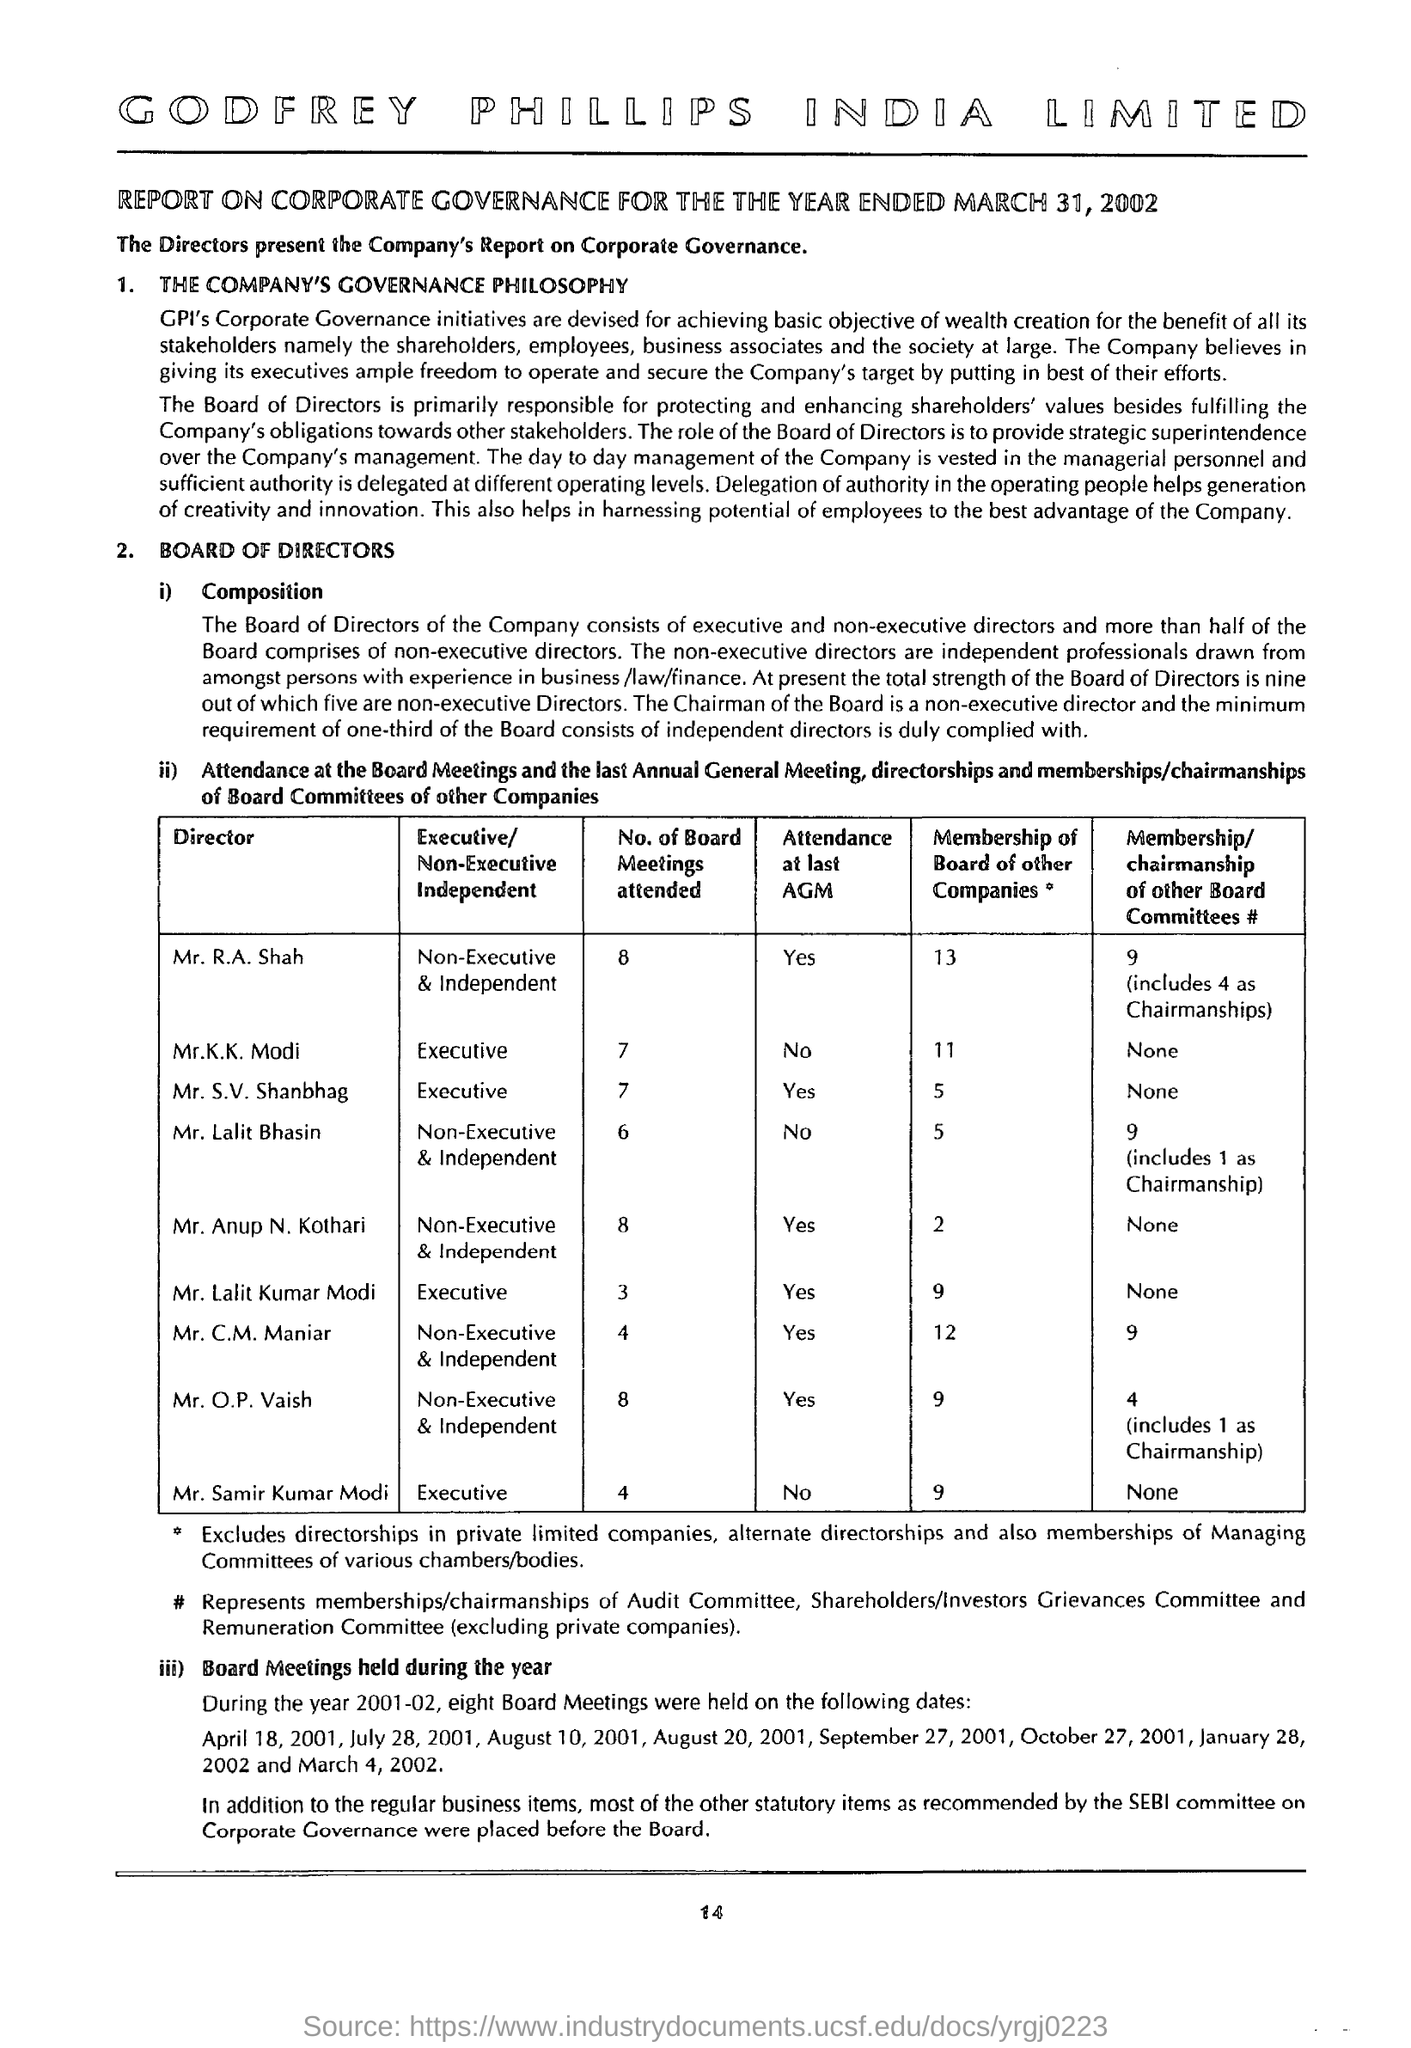Mention a couple of crucial points in this snapshot. There are 12 memberships of the board of other companies for Mr. C.M. Maniar, the director. The director, Mr. O.P. Vaish, attended 8 board meetings. The attendance of Mr. Anup N. Kothari at the last AGM was "yes. The status of attendance at the last AGM for Mr. Lalit Kumar Modi was "yes. The director Mr. K.K. Modi attends 7 board meetings. 